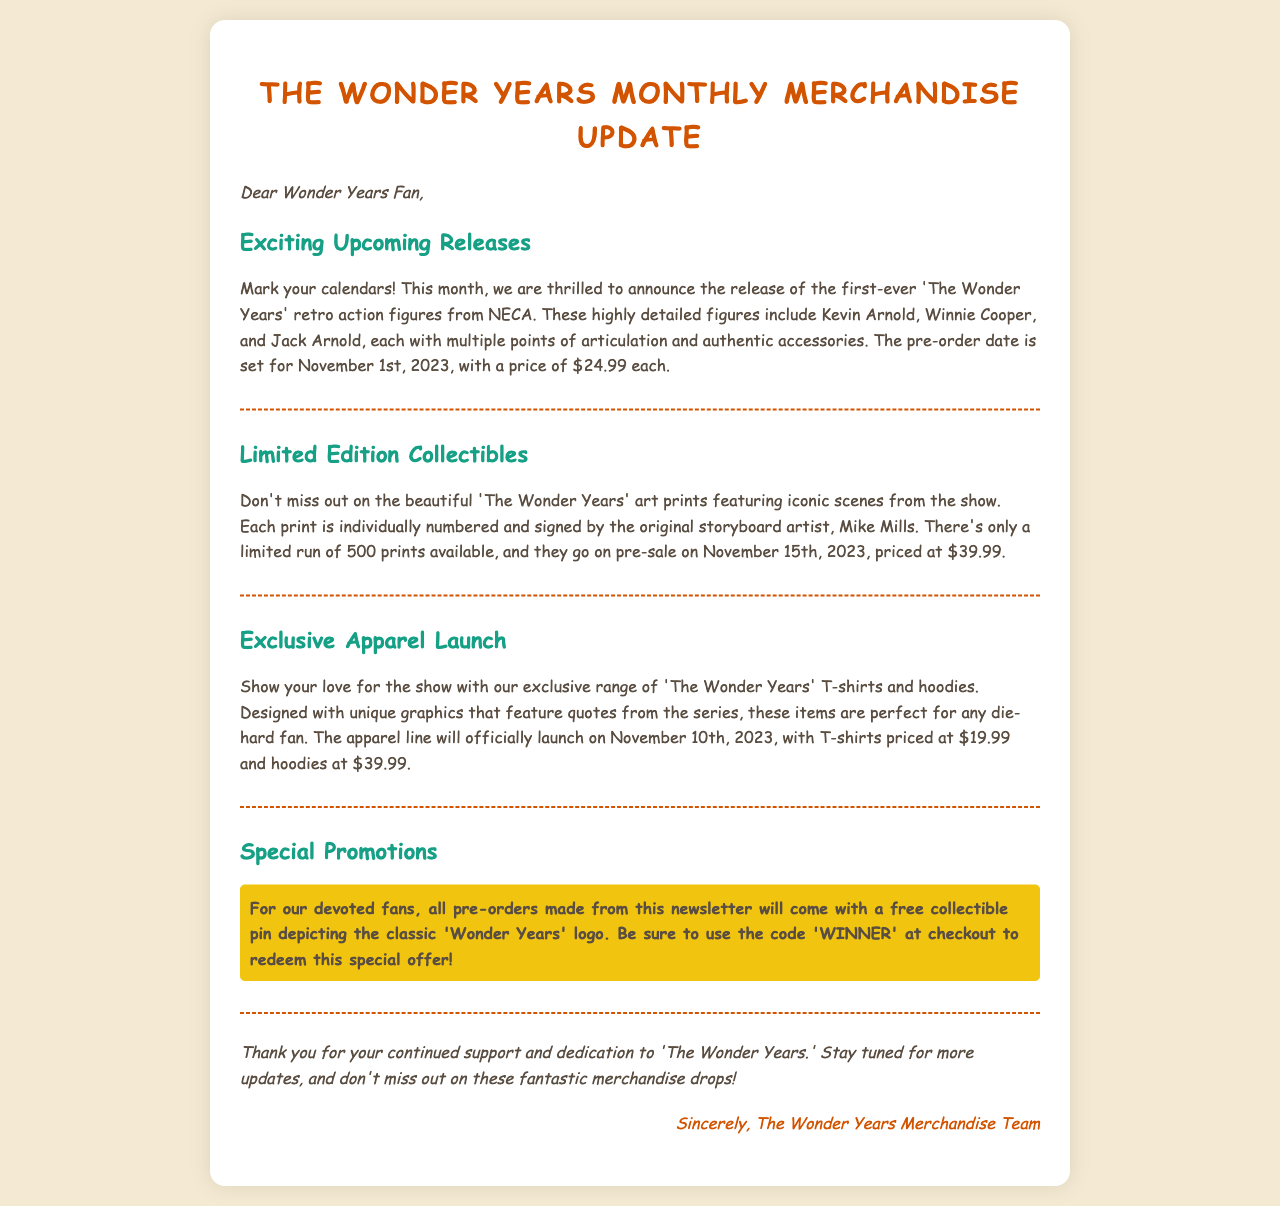What date do the retro action figures go on pre-order? The document states that the pre-order date for the retro action figures is November 1st, 2023.
Answer: November 1st, 2023 How much do the action figures cost? The cost of each action figure is mentioned in the document as $24.99.
Answer: $24.99 What is the price of the art prints? The document provides the price for the art prints, which is $39.99 each.
Answer: $39.99 When is the exclusive apparel line launching? According to the document, the exclusive apparel line will launch on November 10th, 2023.
Answer: November 10th, 2023 What is given for free with all pre-orders? The document mentions that a free collectible pin will be given with all pre-orders.
Answer: Collectible pin How many prints of the art collectibles are available? The document states that there are only 500 prints available for the art collectibles.
Answer: 500 What discount code should be used for the promo? The code provided in the document for the special offer is 'WINNER'.
Answer: WINNER Which characters are included in the retro action figures? The document lists Kevin Arnold, Winnie Cooper, and Jack Arnold as the characters included in the retro action figures.
Answer: Kevin Arnold, Winnie Cooper, Jack Arnold What type of clothing is included in the exclusive apparel? The document details that the exclusive apparel includes T-shirts and hoodies.
Answer: T-shirts and hoodies 